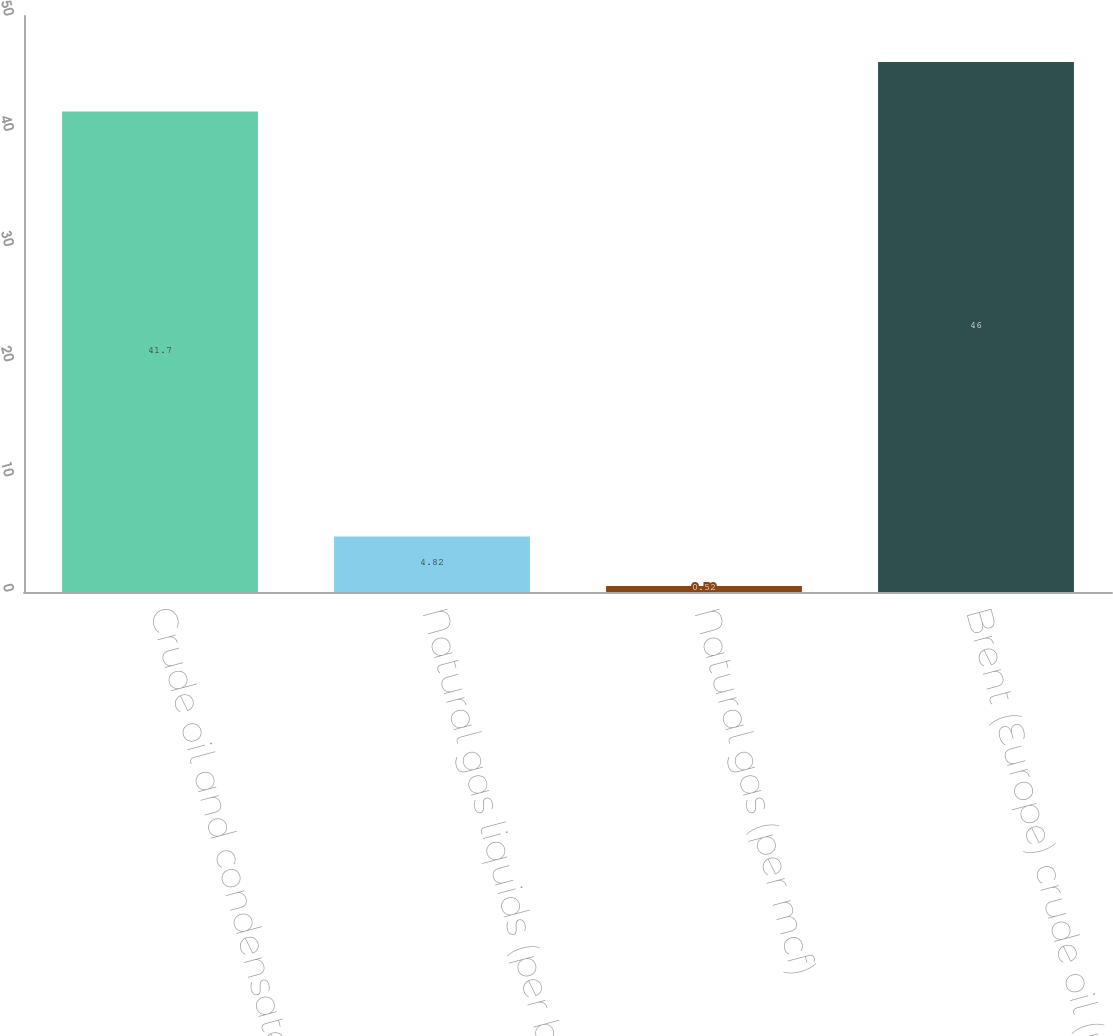Convert chart. <chart><loc_0><loc_0><loc_500><loc_500><bar_chart><fcel>Crude oil and condensate (per<fcel>Natural gas liquids (per bbl)<fcel>Natural gas (per mcf)<fcel>Brent (Europe) crude oil (per<nl><fcel>41.7<fcel>4.82<fcel>0.52<fcel>46<nl></chart> 